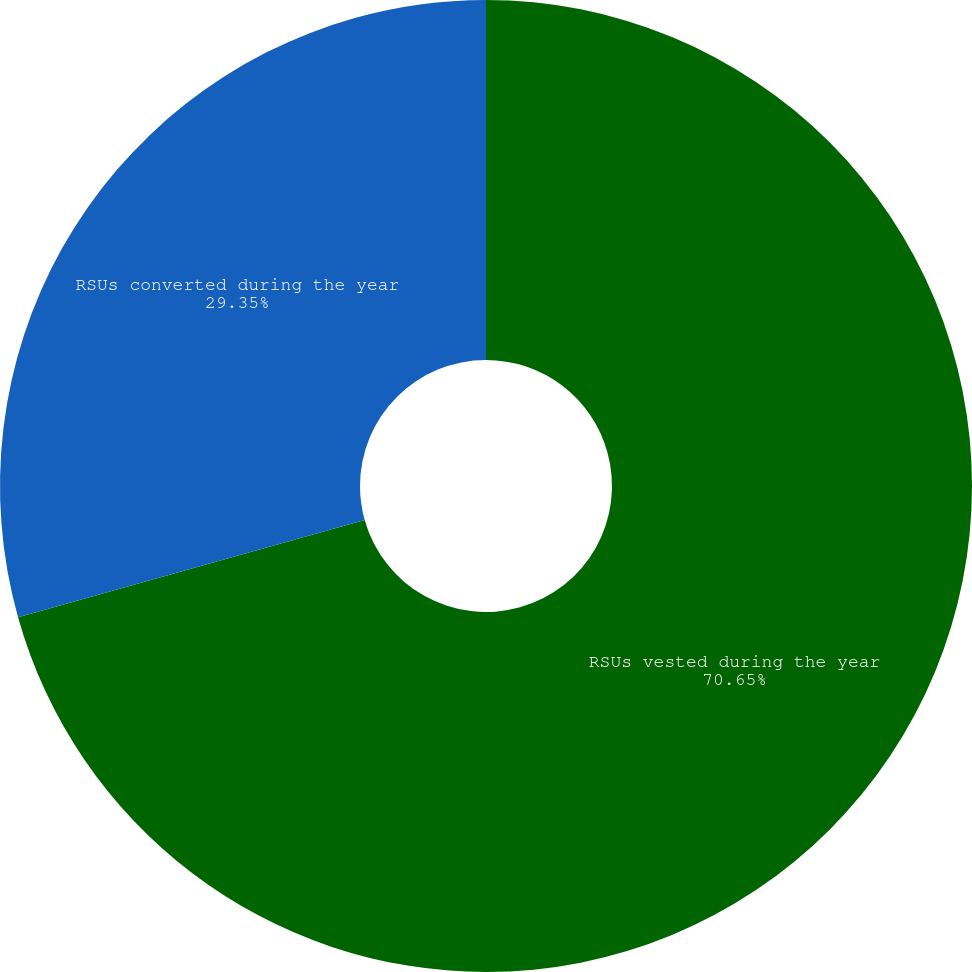<chart> <loc_0><loc_0><loc_500><loc_500><pie_chart><fcel>RSUs vested during the year<fcel>RSUs converted during the year<nl><fcel>70.65%<fcel>29.35%<nl></chart> 